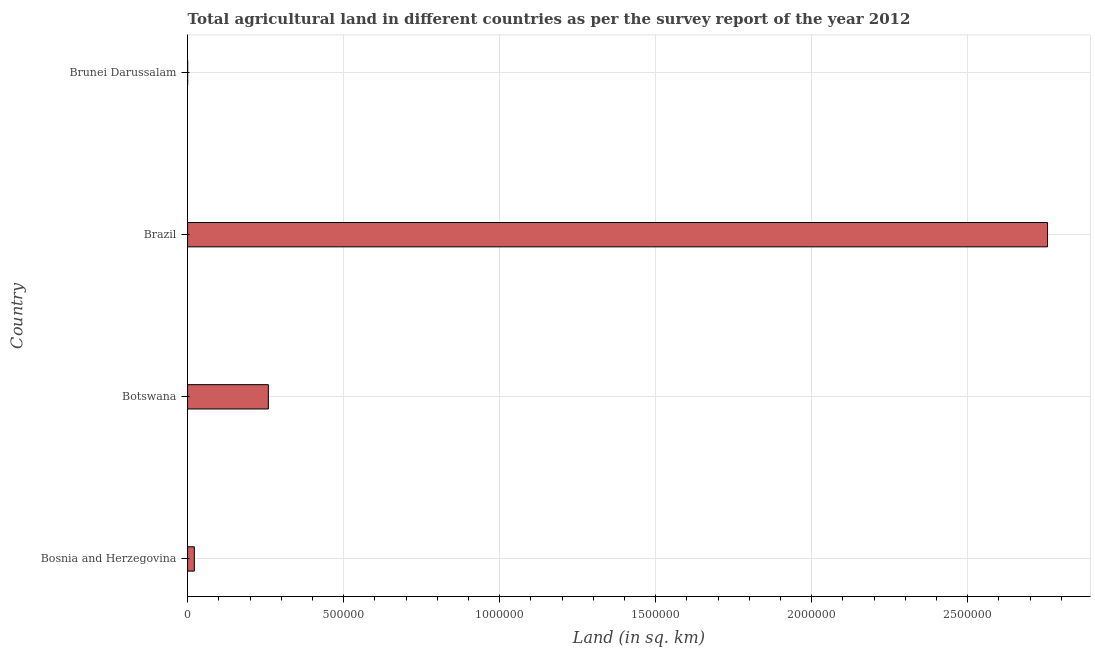What is the title of the graph?
Your answer should be very brief. Total agricultural land in different countries as per the survey report of the year 2012. What is the label or title of the X-axis?
Provide a succinct answer. Land (in sq. km). What is the agricultural land in Bosnia and Herzegovina?
Provide a succinct answer. 2.16e+04. Across all countries, what is the maximum agricultural land?
Your response must be concise. 2.76e+06. Across all countries, what is the minimum agricultural land?
Your answer should be compact. 134. In which country was the agricultural land maximum?
Your response must be concise. Brazil. In which country was the agricultural land minimum?
Make the answer very short. Brunei Darussalam. What is the sum of the agricultural land?
Provide a succinct answer. 3.04e+06. What is the difference between the agricultural land in Brazil and Brunei Darussalam?
Ensure brevity in your answer.  2.76e+06. What is the average agricultural land per country?
Offer a very short reply. 7.59e+05. What is the median agricultural land?
Keep it short and to the point. 1.40e+05. What is the ratio of the agricultural land in Bosnia and Herzegovina to that in Botswana?
Your response must be concise. 0.08. Is the agricultural land in Bosnia and Herzegovina less than that in Botswana?
Ensure brevity in your answer.  Yes. Is the difference between the agricultural land in Bosnia and Herzegovina and Botswana greater than the difference between any two countries?
Your answer should be compact. No. What is the difference between the highest and the second highest agricultural land?
Your response must be concise. 2.50e+06. What is the difference between the highest and the lowest agricultural land?
Your response must be concise. 2.76e+06. In how many countries, is the agricultural land greater than the average agricultural land taken over all countries?
Offer a terse response. 1. How many bars are there?
Provide a succinct answer. 4. Are the values on the major ticks of X-axis written in scientific E-notation?
Offer a very short reply. No. What is the Land (in sq. km) in Bosnia and Herzegovina?
Give a very brief answer. 2.16e+04. What is the Land (in sq. km) in Botswana?
Your answer should be compact. 2.59e+05. What is the Land (in sq. km) in Brazil?
Make the answer very short. 2.76e+06. What is the Land (in sq. km) in Brunei Darussalam?
Make the answer very short. 134. What is the difference between the Land (in sq. km) in Bosnia and Herzegovina and Botswana?
Provide a succinct answer. -2.37e+05. What is the difference between the Land (in sq. km) in Bosnia and Herzegovina and Brazil?
Give a very brief answer. -2.73e+06. What is the difference between the Land (in sq. km) in Bosnia and Herzegovina and Brunei Darussalam?
Ensure brevity in your answer.  2.14e+04. What is the difference between the Land (in sq. km) in Botswana and Brazil?
Your answer should be compact. -2.50e+06. What is the difference between the Land (in sq. km) in Botswana and Brunei Darussalam?
Give a very brief answer. 2.59e+05. What is the difference between the Land (in sq. km) in Brazil and Brunei Darussalam?
Offer a very short reply. 2.76e+06. What is the ratio of the Land (in sq. km) in Bosnia and Herzegovina to that in Botswana?
Your response must be concise. 0.08. What is the ratio of the Land (in sq. km) in Bosnia and Herzegovina to that in Brazil?
Ensure brevity in your answer.  0.01. What is the ratio of the Land (in sq. km) in Bosnia and Herzegovina to that in Brunei Darussalam?
Give a very brief answer. 160.9. What is the ratio of the Land (in sq. km) in Botswana to that in Brazil?
Give a very brief answer. 0.09. What is the ratio of the Land (in sq. km) in Botswana to that in Brunei Darussalam?
Make the answer very short. 1931.87. What is the ratio of the Land (in sq. km) in Brazil to that in Brunei Darussalam?
Make the answer very short. 2.06e+04. 